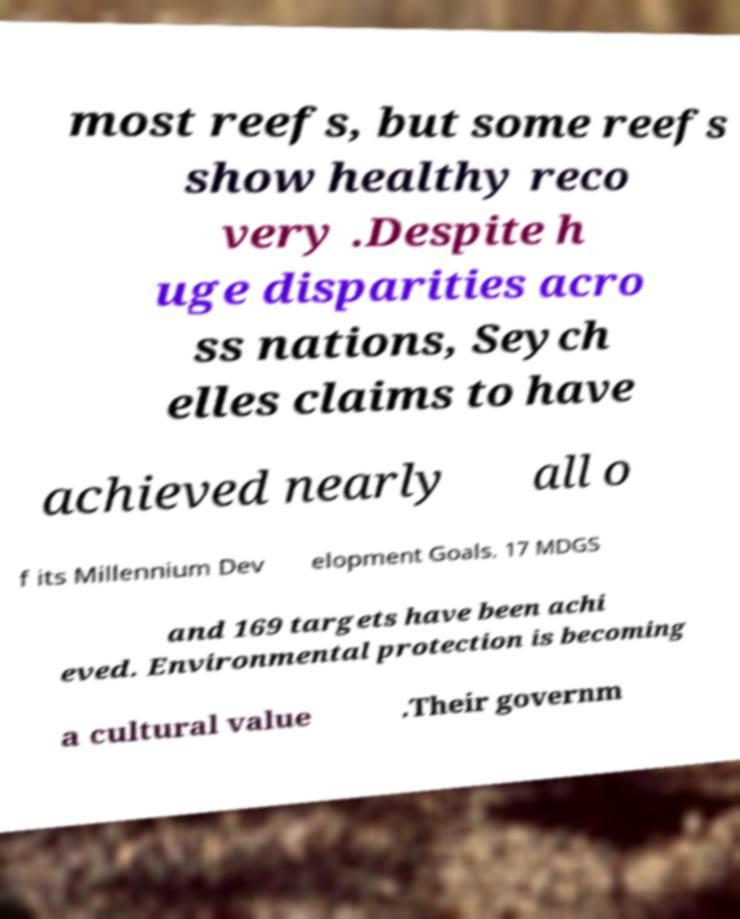There's text embedded in this image that I need extracted. Can you transcribe it verbatim? most reefs, but some reefs show healthy reco very .Despite h uge disparities acro ss nations, Seych elles claims to have achieved nearly all o f its Millennium Dev elopment Goals. 17 MDGS and 169 targets have been achi eved. Environmental protection is becoming a cultural value .Their governm 